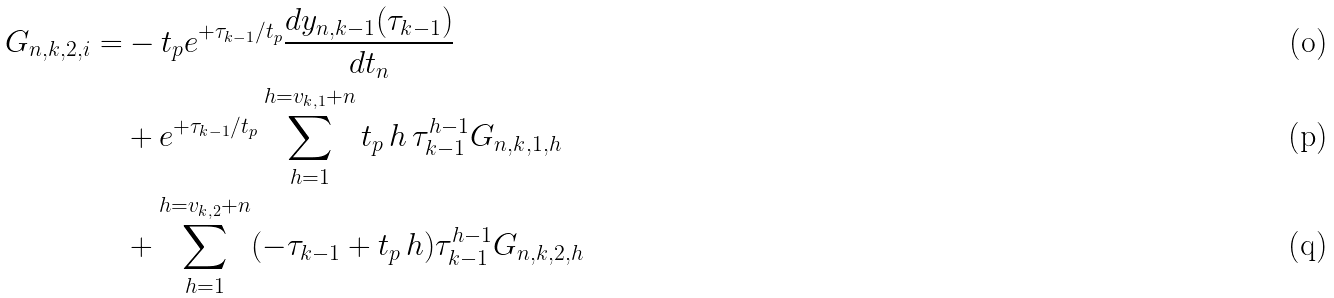<formula> <loc_0><loc_0><loc_500><loc_500>G _ { n , k , 2 , i } = & - t _ { p } e ^ { + \tau _ { k - 1 } / t _ { p } } \frac { d y _ { n , k - 1 } ( \tau _ { k - 1 } ) } { d t _ { n } } \ \\ & + e ^ { + \tau _ { k - 1 } / t _ { p } } \sum _ { h = 1 } ^ { h = v _ { k , 1 } + n } t _ { p } \, h \, \tau _ { k - 1 } ^ { h - 1 } G _ { n , k , 1 , h } \\ & + \sum _ { h = 1 } ^ { h = v _ { k , 2 } + n } ( - \tau _ { k - 1 } + t _ { p } \, h ) \tau _ { k - 1 } ^ { h - 1 } G _ { n , k , 2 , h }</formula> 